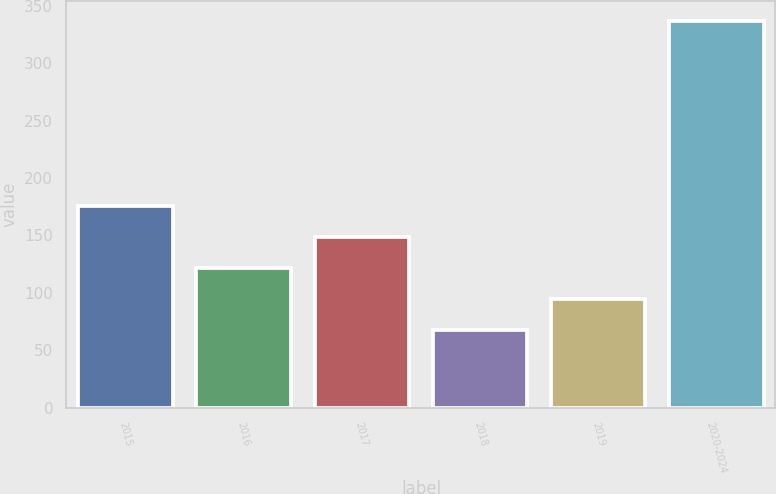<chart> <loc_0><loc_0><loc_500><loc_500><bar_chart><fcel>2015<fcel>2016<fcel>2017<fcel>2018<fcel>2019<fcel>2020-2024<nl><fcel>175.6<fcel>121.8<fcel>148.7<fcel>68<fcel>94.9<fcel>337<nl></chart> 